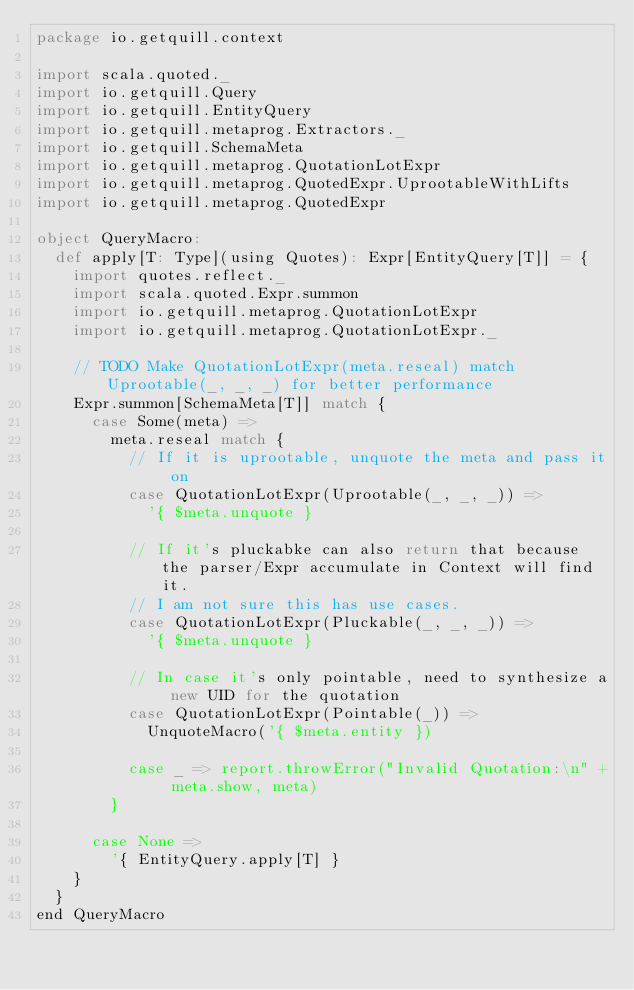<code> <loc_0><loc_0><loc_500><loc_500><_Scala_>package io.getquill.context

import scala.quoted._
import io.getquill.Query
import io.getquill.EntityQuery
import io.getquill.metaprog.Extractors._
import io.getquill.SchemaMeta
import io.getquill.metaprog.QuotationLotExpr
import io.getquill.metaprog.QuotedExpr.UprootableWithLifts
import io.getquill.metaprog.QuotedExpr

object QueryMacro:
  def apply[T: Type](using Quotes): Expr[EntityQuery[T]] = {
    import quotes.reflect._
    import scala.quoted.Expr.summon
    import io.getquill.metaprog.QuotationLotExpr
    import io.getquill.metaprog.QuotationLotExpr._

    // TODO Make QuotationLotExpr(meta.reseal) match Uprootable(_, _, _) for better performance
    Expr.summon[SchemaMeta[T]] match {
      case Some(meta) =>
        meta.reseal match {
          // If it is uprootable, unquote the meta and pass it on
          case QuotationLotExpr(Uprootable(_, _, _)) =>
            '{ $meta.unquote }

          // If it's pluckabke can also return that because the parser/Expr accumulate in Context will find it.
          // I am not sure this has use cases.
          case QuotationLotExpr(Pluckable(_, _, _)) =>
            '{ $meta.unquote }

          // In case it's only pointable, need to synthesize a new UID for the quotation
          case QuotationLotExpr(Pointable(_)) =>
            UnquoteMacro('{ $meta.entity })

          case _ => report.throwError("Invalid Quotation:\n" + meta.show, meta)
        }

      case None =>
        '{ EntityQuery.apply[T] }
    }
  }
end QueryMacro
</code> 